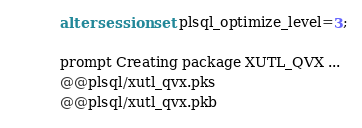<code> <loc_0><loc_0><loc_500><loc_500><_SQL_>alter session set plsql_optimize_level=3;

prompt Creating package XUTL_QVX ...
@@plsql/xutl_qvx.pks
@@plsql/xutl_qvx.pkb
</code> 